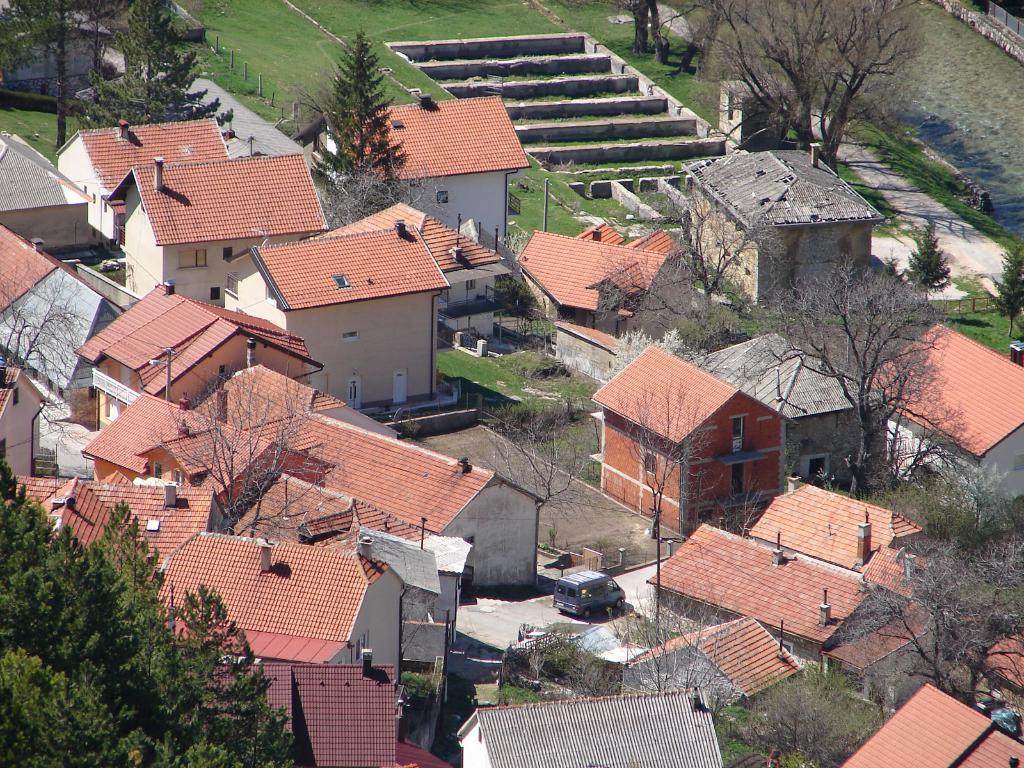What type of vegetation can be seen in the image? There are trees in the image. What type of structures are present in the image? There are hut-shaped buildings in the image. What mode of transportation is parked in the image? A car is parked on the road in the image. Are there any architectural features in the image? Yes, there are stairs in the image. What is the ground covered with in the image? The ground is covered with grass in the image. What natural element is visible in the image? There is water visible in the image. What type of veil is draped over the trees in the image? There is no veil present in the image; it features trees, hut-shaped buildings, a parked car, stairs, grass-covered ground, and water. What type of wool is used to make the stairs in the image? The stairs in the image are not made of wool; they are likely made of wood, concrete, or another material. 